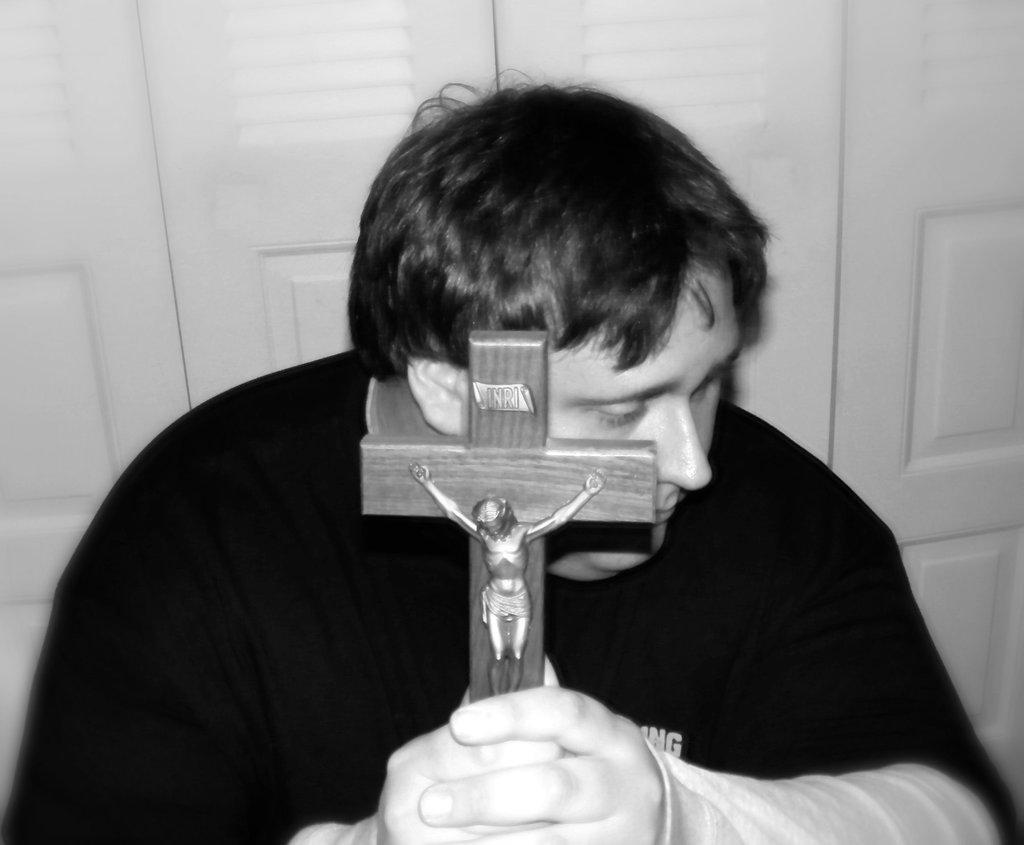Describe this image in one or two sentences. In this image I can see a person is holding the cross symbol and I can see a statue on it. The image is in black and white. 